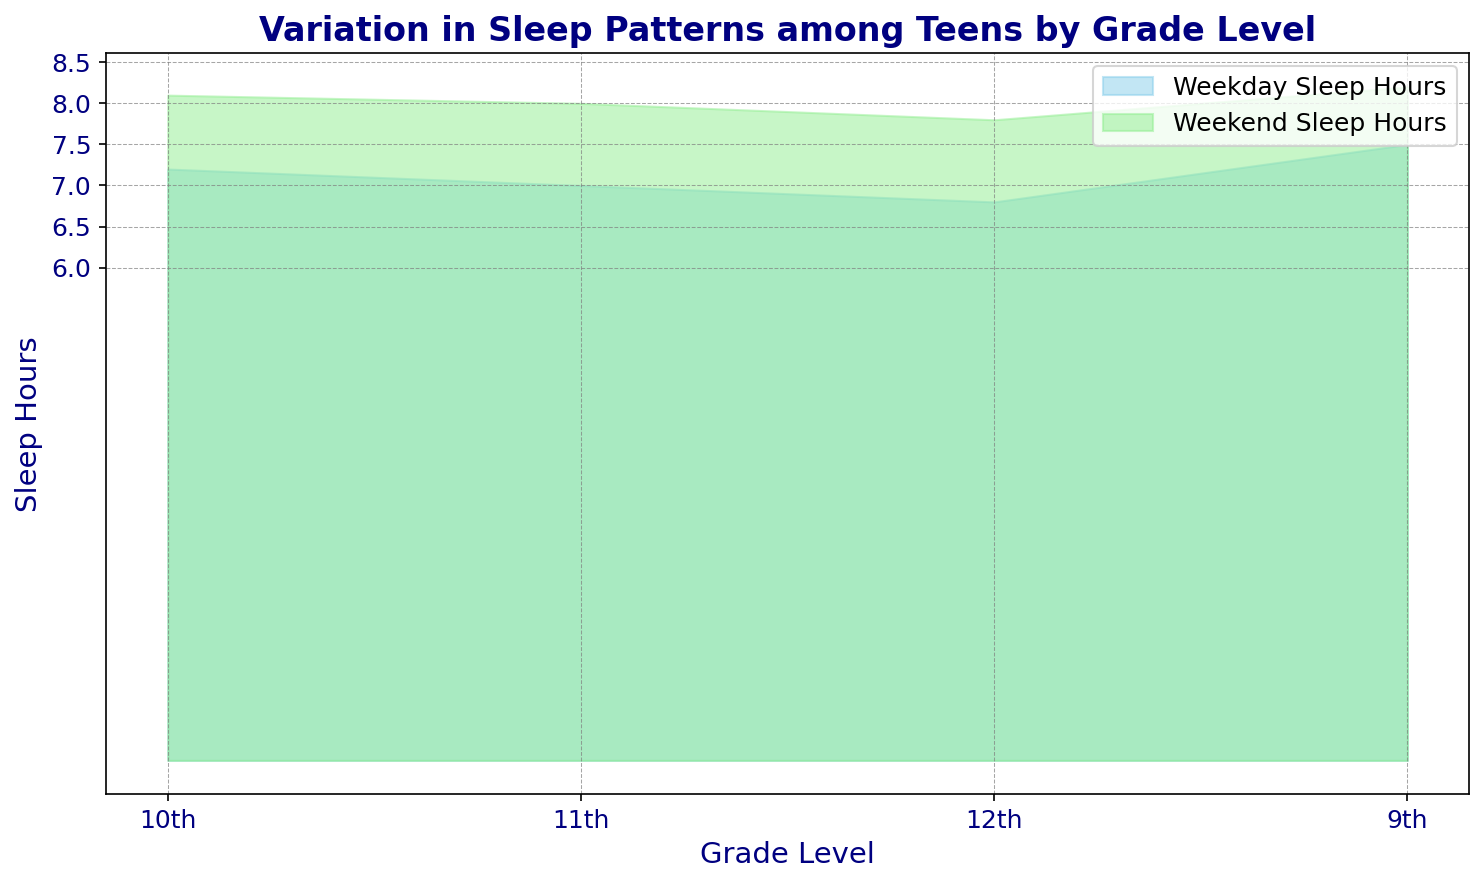What are the grade levels represented in the chart? The grade levels are displayed on the x-axis of the chart. By looking at the labels, you can identify the different grade levels presented in the data.
Answer: 9th, 10th, 11th, 12th Which grade level has the highest median weekday sleep hours? By comparing the height of the blue area corresponding to weekday sleep hours across different grade levels, we can see that the 9th grade level has the highest y-value in the blue area.
Answer: 9th Which grade level has the lowest median weekday sleep hours? By comparing the height of the blue area corresponding to weekday sleep hours across different grade levels, we can see that the 12th grade level has the lowest y-value in the blue area.
Answer: 12th How do weekend sleep hours for 11th graders compare to that for 10th graders? Look at the height of the green area associated with weekend sleep hours for both 11th and 10th grade levels. The 11th grade level has slightly higher y-values in the green area compared to the 10th grade level.
Answer: Higher What is the difference in median weekend sleep hours between 9th and 12th graders? To find the difference, look at the green areas for 9th and 12th graders and identify their heights on the y-axis. The 9th graders have about 8.2 hours, and the 12th graders have about 7.8 hours. Subtract 7.8 from 8.2.
Answer: 0.4 hours Which grade level shows the greatest difference between weekday and weekend sleep hours? Calculate the difference between the weekday (blue) and weekend (green) sleep hours for each grade level. The grade with the largest vertical distance between the blue and green areas has the greatest difference. This appears highest for the 9th grade.
Answer: 9th What trend is observed in the median weekday sleep hours as students progress from 9th to 12th grade? Observe the blue area from left to right (9th to 12th grade). The height of the blue area (weekday sleep hours) decreases as the grade level increases.
Answer: Decreases By how much do the median weekday sleep hours decrease from 9th to 12th grade? To find the decrease, subtract the median weekday sleep hours of the 12th graders from those of the 9th graders. The values are about 7.5 for 9th graders and 6.8 for 12th graders. So, 7.5 - 6.8 = 0.7.
Answer: 0.7 hours In which grade do students have the smallest difference between weekday and weekend sleep hours? Compare the vertical distances between the blue and green areas for all grade levels. The 10th grade shows the smallest difference as the blue and green areas are closest together.
Answer: 10th 